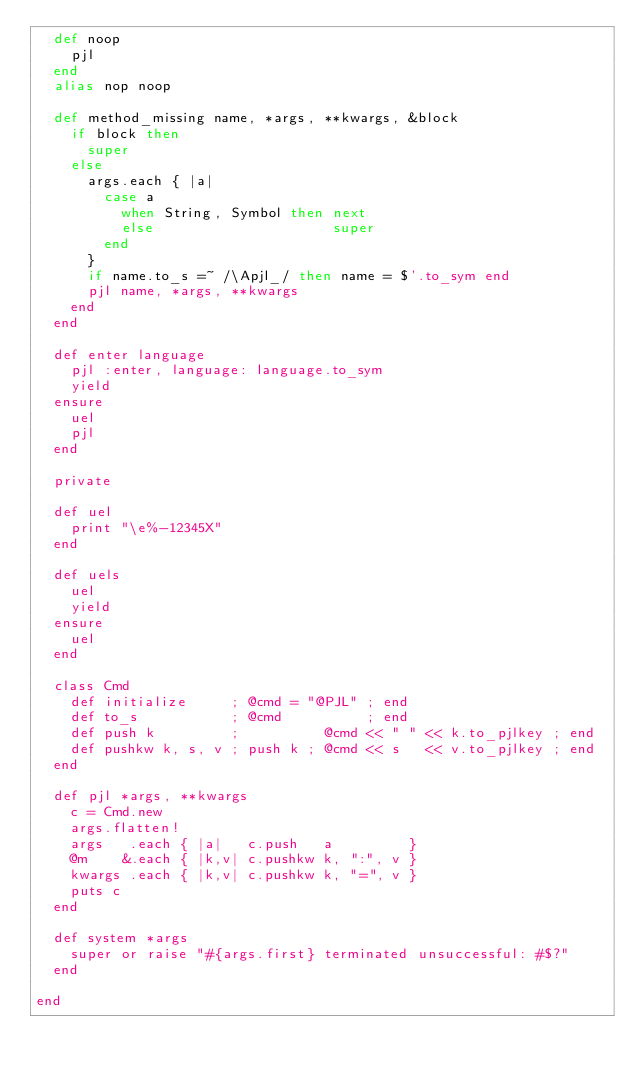Convert code to text. <code><loc_0><loc_0><loc_500><loc_500><_Ruby_>  def noop
    pjl
  end
  alias nop noop

  def method_missing name, *args, **kwargs, &block
    if block then
      super
    else
      args.each { |a|
        case a
          when String, Symbol then next
          else                     super
        end
      }
      if name.to_s =~ /\Apjl_/ then name = $'.to_sym end
      pjl name, *args, **kwargs
    end
  end

  def enter language
    pjl :enter, language: language.to_sym
    yield
  ensure
    uel
    pjl
  end

  private

  def uel
    print "\e%-12345X"
  end

  def uels
    uel
    yield
  ensure
    uel
  end

  class Cmd
    def initialize     ; @cmd = "@PJL" ; end
    def to_s           ; @cmd          ; end
    def push k         ;          @cmd << " " << k.to_pjlkey ; end
    def pushkw k, s, v ; push k ; @cmd << s   << v.to_pjlkey ; end
  end

  def pjl *args, **kwargs
    c = Cmd.new
    args.flatten!
    args   .each { |a|   c.push   a         }
    @m    &.each { |k,v| c.pushkw k, ":", v }
    kwargs .each { |k,v| c.pushkw k, "=", v }
    puts c
  end

  def system *args
    super or raise "#{args.first} terminated unsuccessful: #$?"
  end

end

</code> 